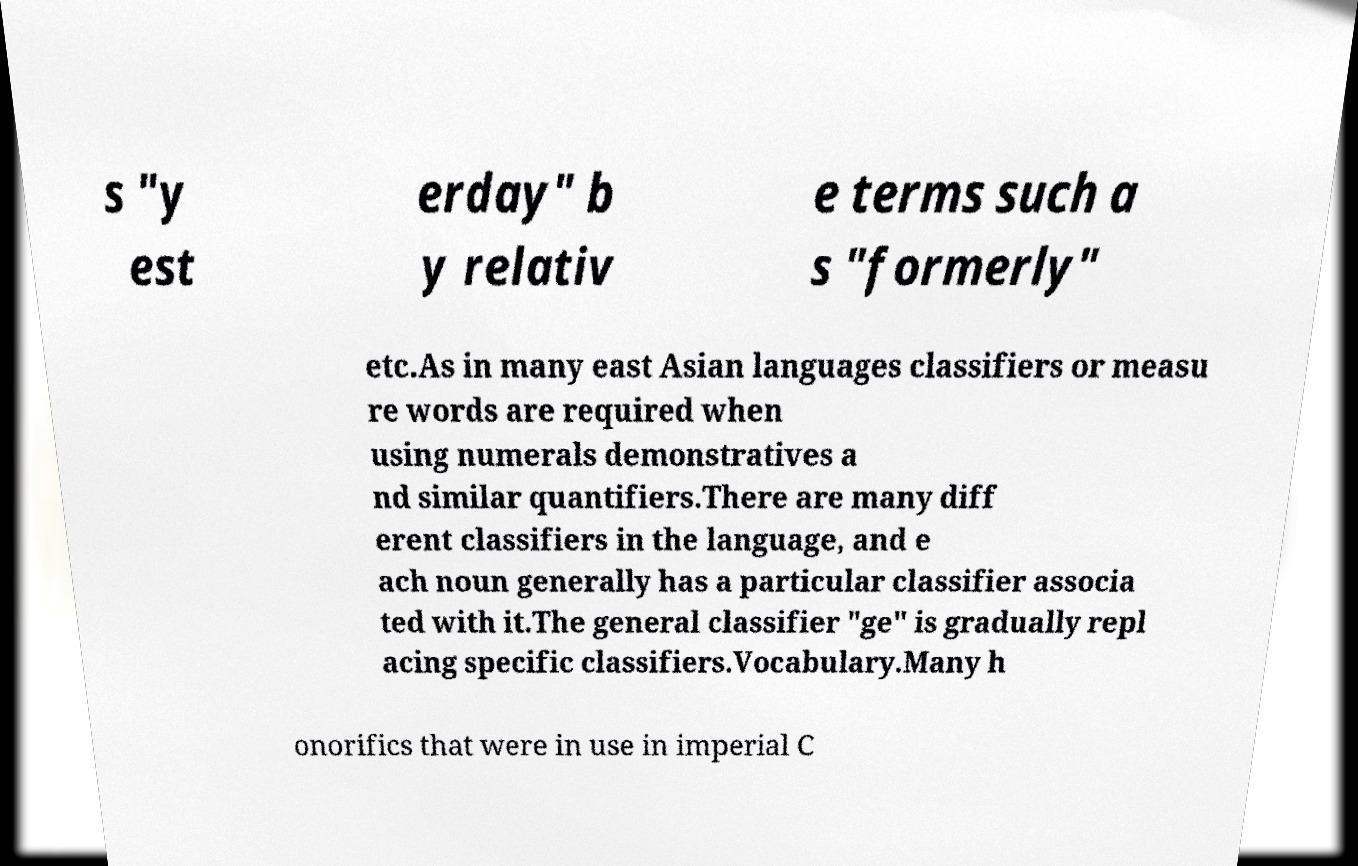Please read and relay the text visible in this image. What does it say? s "y est erday" b y relativ e terms such a s "formerly" etc.As in many east Asian languages classifiers or measu re words are required when using numerals demonstratives a nd similar quantifiers.There are many diff erent classifiers in the language, and e ach noun generally has a particular classifier associa ted with it.The general classifier "ge" is gradually repl acing specific classifiers.Vocabulary.Many h onorifics that were in use in imperial C 